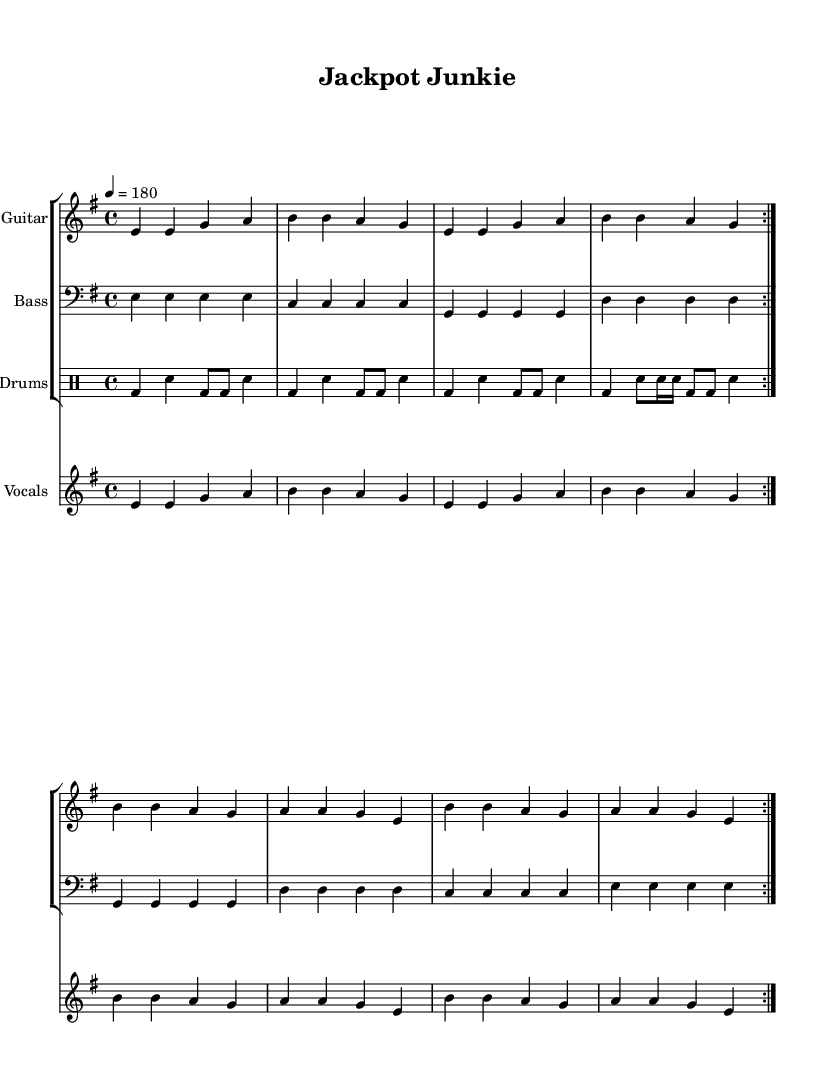What is the key signature of this music? The key signature is indicated at the beginning of the music, showing an E minor, which has one sharp (F#).
Answer: E minor What is the time signature of this music? The time signature is specified next to the key signature, represented as 4/4, indicating four beats per measure.
Answer: 4/4 What is the tempo marking for this piece? The tempo marking is given as "4 = 180", which signifies that there are 180 quarter-note beats in one minute, indicating a fast pace.
Answer: 180 How many measures are in the repeated section for the electric guitar? The repeated section of the music for the electric guitar consists of eight measures that are labeled with "volta 2", indicating the repetition.
Answer: 8 What is the primary theme of the lyrics? The lyrics reflect a theme focused on the consequences of gambling addiction, using phrases like "Jackpot junkie" and "gambling your life away".
Answer: Consequences of gambling addiction What instrument plays the final notes in the song? The final notes are performed by the vocals, which echo the repeated phrases, emphasizing the message.
Answer: Vocals What type of rhythm pattern is used in the drums? The drums follow a consistent rhythm pattern with bass drums and snare hits, alternating throughout the piece, and creating an energetic feel characteristic of punk music.
Answer: Energetic rhythm pattern 